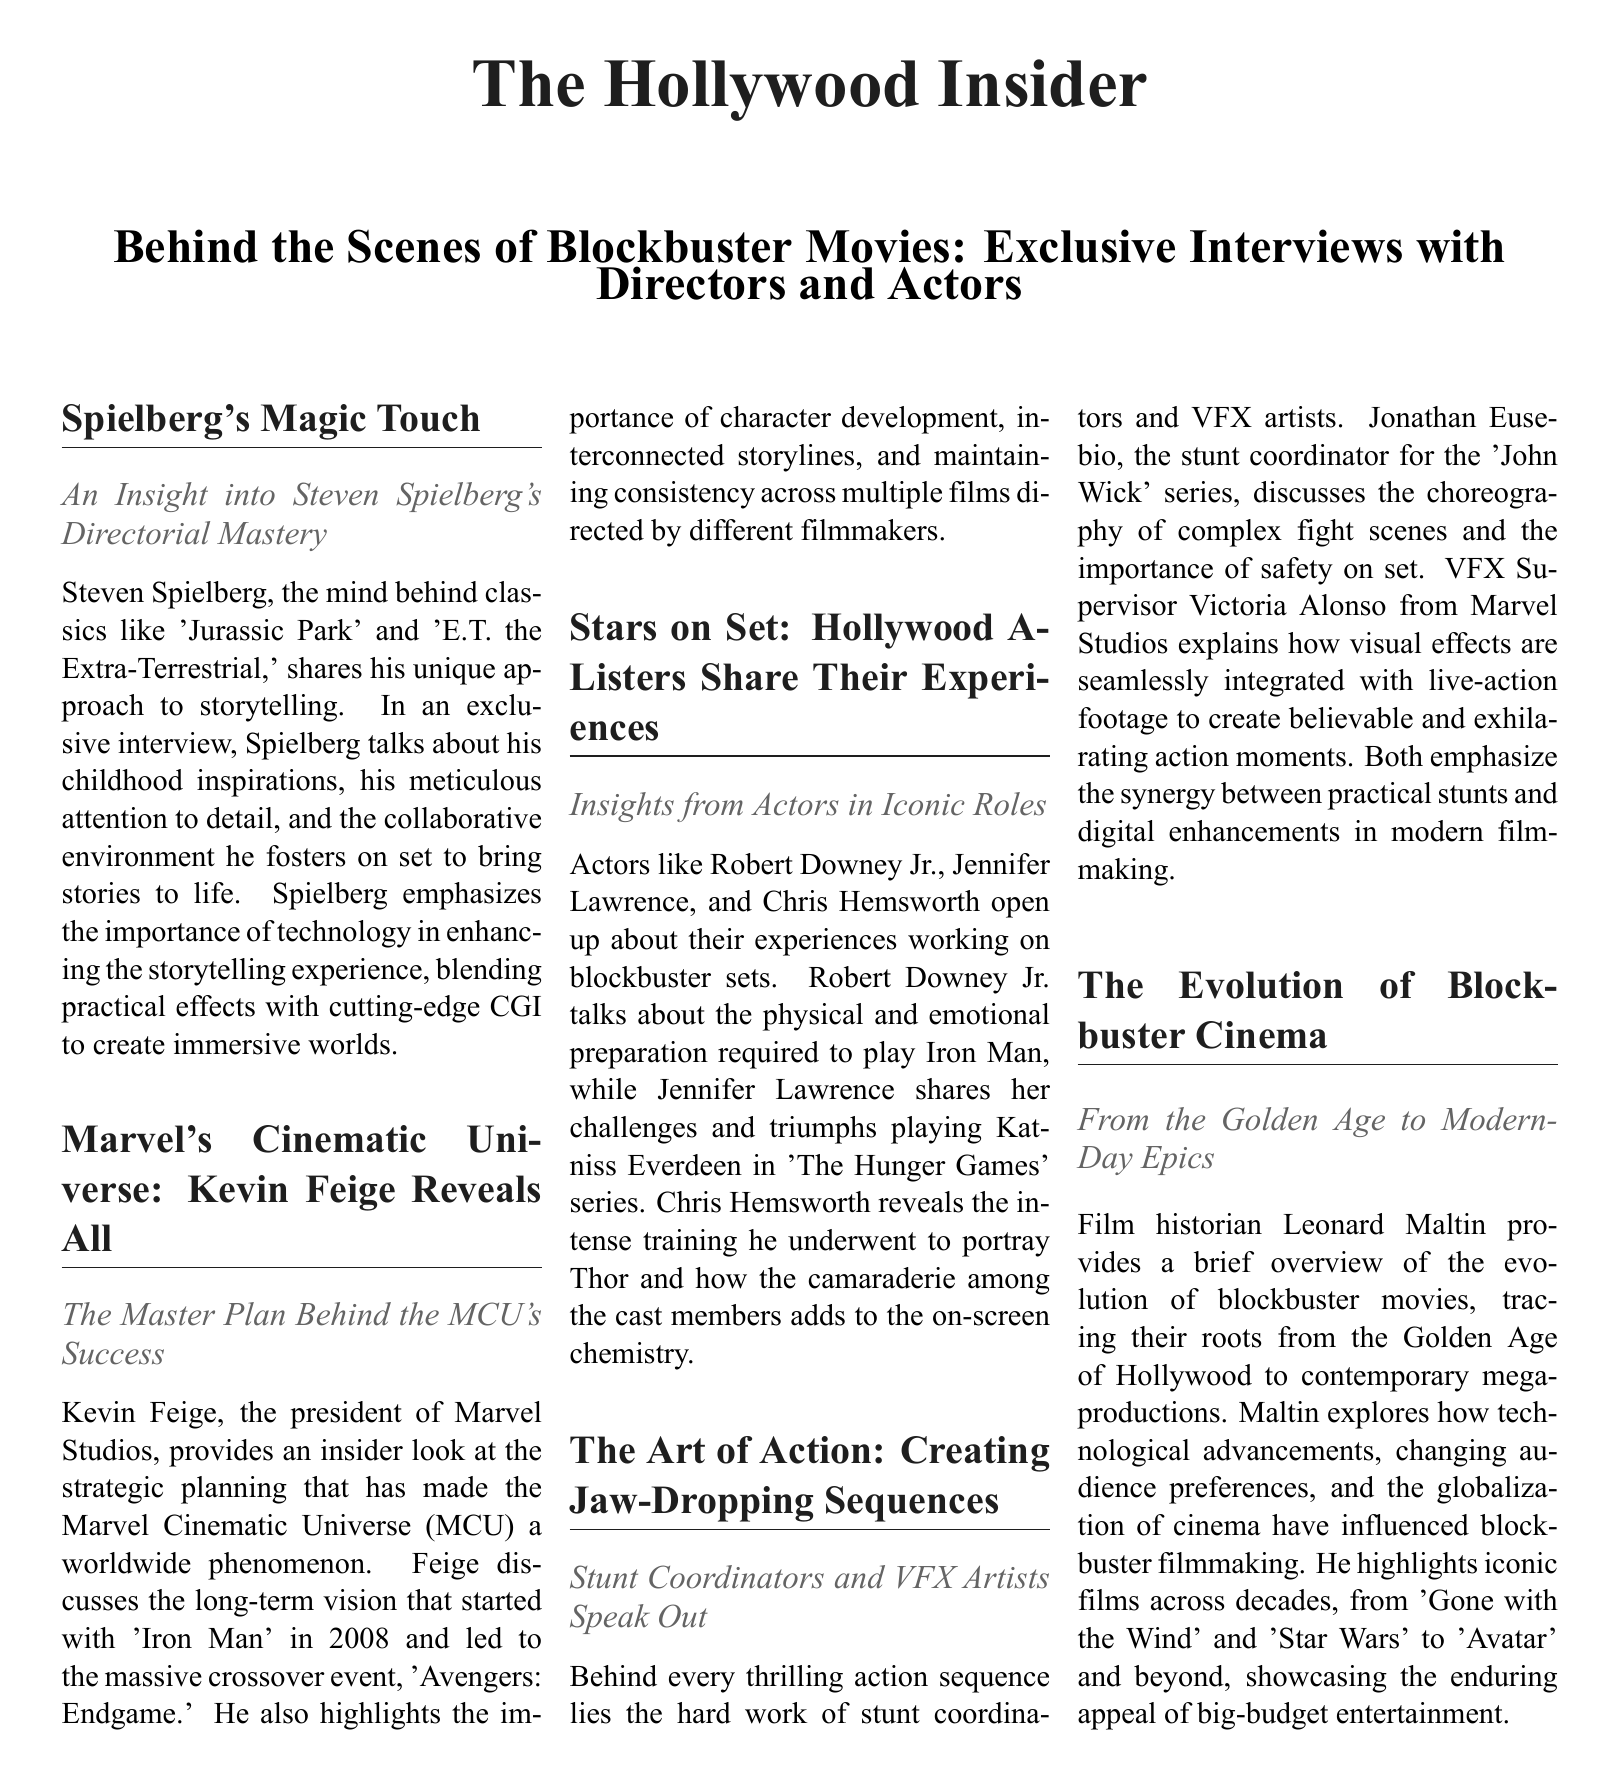What is the title of the document? The title of the document is mentioned at the top of the newspaper layout.
Answer: The Hollywood Insider Who directed "Jurassic Park"? The document provides insights into the director of "Jurassic Park."
Answer: Steven Spielberg What role did Jennifer Lawrence play in "The Hunger Games"? The document specifies the iconic character Jennifer Lawrence portrayed in the film series.
Answer: Katniss Everdeen Who is the president of Marvel Studios? The document identifies a key figure responsible for the success of the MCU.
Answer: Kevin Feige What is the name of the stunt coordinator for the "John Wick" series? The document includes information about the individual responsible for choreographing fight scenes in the series.
Answer: Jonathan Eusebio What year did "Iron Man" release? The document discusses the starting point of the MCU's long-term vision.
Answer: 2008 What is emphasized as important in creating action sequences? The document highlights key elements that contribute to the thrilling nature of action scenes in films.
Answer: Safety What film historian contributed to the document? The document mentions a film historian who provides an overview of blockbuster cinema.
Answer: Leonard Maltin How does the document categorize its content? The structure of the document includes several sections and subsections.
Answer: Newspaper layout 